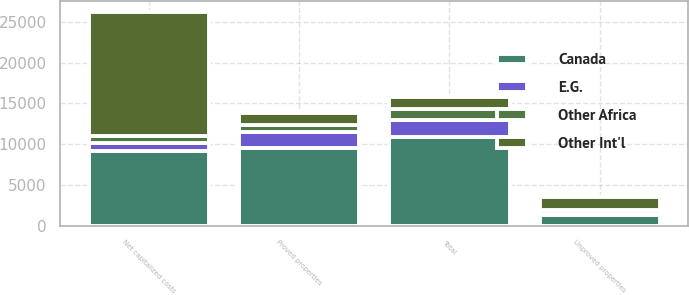Convert chart. <chart><loc_0><loc_0><loc_500><loc_500><stacked_bar_chart><ecel><fcel>Proved properties<fcel>Unproved properties<fcel>Total<fcel>Net capitalized costs<nl><fcel>Other Int'l<fcel>1507<fcel>1625<fcel>1507<fcel>15110<nl><fcel>Canada<fcel>9538<fcel>1389<fcel>10927<fcel>9197<nl><fcel>E.G.<fcel>1955<fcel>86<fcel>2041<fcel>936<nl><fcel>Other Africa<fcel>828<fcel>465<fcel>1293<fcel>923<nl></chart> 